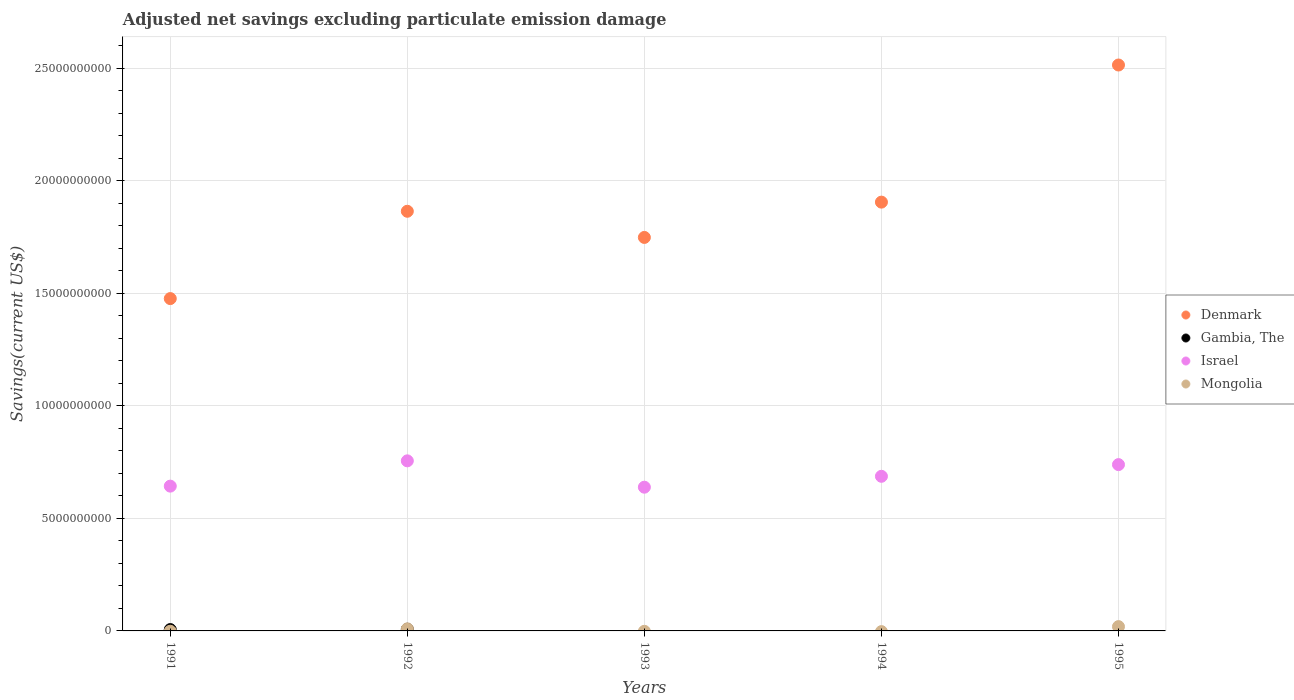How many different coloured dotlines are there?
Offer a very short reply. 4. What is the adjusted net savings in Mongolia in 1991?
Provide a short and direct response. 0. Across all years, what is the maximum adjusted net savings in Israel?
Ensure brevity in your answer.  7.56e+09. Across all years, what is the minimum adjusted net savings in Denmark?
Make the answer very short. 1.48e+1. In which year was the adjusted net savings in Mongolia maximum?
Give a very brief answer. 1995. What is the total adjusted net savings in Denmark in the graph?
Provide a succinct answer. 9.51e+1. What is the difference between the adjusted net savings in Denmark in 1991 and that in 1992?
Keep it short and to the point. -3.88e+09. What is the difference between the adjusted net savings in Gambia, The in 1993 and the adjusted net savings in Mongolia in 1992?
Give a very brief answer. -9.14e+07. What is the average adjusted net savings in Gambia, The per year?
Your answer should be compact. 2.71e+07. In the year 1995, what is the difference between the adjusted net savings in Israel and adjusted net savings in Denmark?
Ensure brevity in your answer.  -1.78e+1. In how many years, is the adjusted net savings in Israel greater than 10000000000 US$?
Your answer should be compact. 0. What is the ratio of the adjusted net savings in Denmark in 1992 to that in 1995?
Keep it short and to the point. 0.74. Is the difference between the adjusted net savings in Israel in 1993 and 1994 greater than the difference between the adjusted net savings in Denmark in 1993 and 1994?
Offer a very short reply. Yes. What is the difference between the highest and the second highest adjusted net savings in Denmark?
Provide a succinct answer. 6.10e+09. What is the difference between the highest and the lowest adjusted net savings in Mongolia?
Your answer should be very brief. 1.91e+08. In how many years, is the adjusted net savings in Israel greater than the average adjusted net savings in Israel taken over all years?
Make the answer very short. 2. Does the adjusted net savings in Denmark monotonically increase over the years?
Offer a terse response. No. Is the adjusted net savings in Gambia, The strictly greater than the adjusted net savings in Israel over the years?
Provide a succinct answer. No. Is the adjusted net savings in Gambia, The strictly less than the adjusted net savings in Israel over the years?
Your answer should be very brief. Yes. How many dotlines are there?
Your answer should be very brief. 4. Are the values on the major ticks of Y-axis written in scientific E-notation?
Offer a very short reply. No. Does the graph contain any zero values?
Offer a very short reply. Yes. Where does the legend appear in the graph?
Keep it short and to the point. Center right. How many legend labels are there?
Provide a short and direct response. 4. How are the legend labels stacked?
Provide a succinct answer. Vertical. What is the title of the graph?
Ensure brevity in your answer.  Adjusted net savings excluding particulate emission damage. What is the label or title of the X-axis?
Make the answer very short. Years. What is the label or title of the Y-axis?
Your response must be concise. Savings(current US$). What is the Savings(current US$) in Denmark in 1991?
Offer a terse response. 1.48e+1. What is the Savings(current US$) in Gambia, The in 1991?
Your response must be concise. 5.98e+07. What is the Savings(current US$) of Israel in 1991?
Your answer should be compact. 6.44e+09. What is the Savings(current US$) of Denmark in 1992?
Keep it short and to the point. 1.87e+1. What is the Savings(current US$) of Gambia, The in 1992?
Ensure brevity in your answer.  7.57e+07. What is the Savings(current US$) in Israel in 1992?
Provide a short and direct response. 7.56e+09. What is the Savings(current US$) of Mongolia in 1992?
Keep it short and to the point. 9.14e+07. What is the Savings(current US$) of Denmark in 1993?
Give a very brief answer. 1.75e+1. What is the Savings(current US$) in Israel in 1993?
Ensure brevity in your answer.  6.39e+09. What is the Savings(current US$) in Denmark in 1994?
Your answer should be compact. 1.91e+1. What is the Savings(current US$) in Israel in 1994?
Provide a short and direct response. 6.87e+09. What is the Savings(current US$) in Denmark in 1995?
Ensure brevity in your answer.  2.52e+1. What is the Savings(current US$) in Israel in 1995?
Keep it short and to the point. 7.39e+09. What is the Savings(current US$) in Mongolia in 1995?
Your answer should be compact. 1.91e+08. Across all years, what is the maximum Savings(current US$) of Denmark?
Offer a terse response. 2.52e+1. Across all years, what is the maximum Savings(current US$) of Gambia, The?
Your response must be concise. 7.57e+07. Across all years, what is the maximum Savings(current US$) of Israel?
Provide a short and direct response. 7.56e+09. Across all years, what is the maximum Savings(current US$) in Mongolia?
Your answer should be compact. 1.91e+08. Across all years, what is the minimum Savings(current US$) of Denmark?
Your response must be concise. 1.48e+1. Across all years, what is the minimum Savings(current US$) in Gambia, The?
Your answer should be very brief. 0. Across all years, what is the minimum Savings(current US$) of Israel?
Make the answer very short. 6.39e+09. Across all years, what is the minimum Savings(current US$) in Mongolia?
Provide a short and direct response. 0. What is the total Savings(current US$) in Denmark in the graph?
Keep it short and to the point. 9.51e+1. What is the total Savings(current US$) of Gambia, The in the graph?
Offer a very short reply. 1.35e+08. What is the total Savings(current US$) of Israel in the graph?
Make the answer very short. 3.47e+1. What is the total Savings(current US$) of Mongolia in the graph?
Your response must be concise. 2.83e+08. What is the difference between the Savings(current US$) in Denmark in 1991 and that in 1992?
Your answer should be very brief. -3.88e+09. What is the difference between the Savings(current US$) of Gambia, The in 1991 and that in 1992?
Provide a succinct answer. -1.58e+07. What is the difference between the Savings(current US$) of Israel in 1991 and that in 1992?
Give a very brief answer. -1.12e+09. What is the difference between the Savings(current US$) in Denmark in 1991 and that in 1993?
Offer a very short reply. -2.72e+09. What is the difference between the Savings(current US$) of Israel in 1991 and that in 1993?
Offer a terse response. 4.69e+07. What is the difference between the Savings(current US$) in Denmark in 1991 and that in 1994?
Your answer should be compact. -4.29e+09. What is the difference between the Savings(current US$) of Israel in 1991 and that in 1994?
Provide a short and direct response. -4.37e+08. What is the difference between the Savings(current US$) in Denmark in 1991 and that in 1995?
Offer a very short reply. -1.04e+1. What is the difference between the Savings(current US$) in Israel in 1991 and that in 1995?
Make the answer very short. -9.57e+08. What is the difference between the Savings(current US$) in Denmark in 1992 and that in 1993?
Provide a short and direct response. 1.16e+09. What is the difference between the Savings(current US$) of Israel in 1992 and that in 1993?
Ensure brevity in your answer.  1.17e+09. What is the difference between the Savings(current US$) of Denmark in 1992 and that in 1994?
Provide a succinct answer. -4.06e+08. What is the difference between the Savings(current US$) in Israel in 1992 and that in 1994?
Give a very brief answer. 6.87e+08. What is the difference between the Savings(current US$) of Denmark in 1992 and that in 1995?
Give a very brief answer. -6.50e+09. What is the difference between the Savings(current US$) of Israel in 1992 and that in 1995?
Provide a short and direct response. 1.68e+08. What is the difference between the Savings(current US$) in Mongolia in 1992 and that in 1995?
Provide a short and direct response. -9.98e+07. What is the difference between the Savings(current US$) of Denmark in 1993 and that in 1994?
Provide a succinct answer. -1.57e+09. What is the difference between the Savings(current US$) of Israel in 1993 and that in 1994?
Ensure brevity in your answer.  -4.84e+08. What is the difference between the Savings(current US$) in Denmark in 1993 and that in 1995?
Keep it short and to the point. -7.66e+09. What is the difference between the Savings(current US$) of Israel in 1993 and that in 1995?
Keep it short and to the point. -1.00e+09. What is the difference between the Savings(current US$) in Denmark in 1994 and that in 1995?
Your response must be concise. -6.10e+09. What is the difference between the Savings(current US$) of Israel in 1994 and that in 1995?
Give a very brief answer. -5.19e+08. What is the difference between the Savings(current US$) in Denmark in 1991 and the Savings(current US$) in Gambia, The in 1992?
Make the answer very short. 1.47e+1. What is the difference between the Savings(current US$) in Denmark in 1991 and the Savings(current US$) in Israel in 1992?
Ensure brevity in your answer.  7.21e+09. What is the difference between the Savings(current US$) of Denmark in 1991 and the Savings(current US$) of Mongolia in 1992?
Give a very brief answer. 1.47e+1. What is the difference between the Savings(current US$) in Gambia, The in 1991 and the Savings(current US$) in Israel in 1992?
Ensure brevity in your answer.  -7.50e+09. What is the difference between the Savings(current US$) in Gambia, The in 1991 and the Savings(current US$) in Mongolia in 1992?
Make the answer very short. -3.15e+07. What is the difference between the Savings(current US$) in Israel in 1991 and the Savings(current US$) in Mongolia in 1992?
Ensure brevity in your answer.  6.34e+09. What is the difference between the Savings(current US$) of Denmark in 1991 and the Savings(current US$) of Israel in 1993?
Provide a succinct answer. 8.38e+09. What is the difference between the Savings(current US$) of Gambia, The in 1991 and the Savings(current US$) of Israel in 1993?
Ensure brevity in your answer.  -6.33e+09. What is the difference between the Savings(current US$) in Denmark in 1991 and the Savings(current US$) in Israel in 1994?
Provide a succinct answer. 7.90e+09. What is the difference between the Savings(current US$) of Gambia, The in 1991 and the Savings(current US$) of Israel in 1994?
Your response must be concise. -6.81e+09. What is the difference between the Savings(current US$) of Denmark in 1991 and the Savings(current US$) of Israel in 1995?
Provide a short and direct response. 7.38e+09. What is the difference between the Savings(current US$) of Denmark in 1991 and the Savings(current US$) of Mongolia in 1995?
Your answer should be very brief. 1.46e+1. What is the difference between the Savings(current US$) in Gambia, The in 1991 and the Savings(current US$) in Israel in 1995?
Provide a succinct answer. -7.33e+09. What is the difference between the Savings(current US$) of Gambia, The in 1991 and the Savings(current US$) of Mongolia in 1995?
Give a very brief answer. -1.31e+08. What is the difference between the Savings(current US$) of Israel in 1991 and the Savings(current US$) of Mongolia in 1995?
Your answer should be very brief. 6.24e+09. What is the difference between the Savings(current US$) of Denmark in 1992 and the Savings(current US$) of Israel in 1993?
Offer a terse response. 1.23e+1. What is the difference between the Savings(current US$) in Gambia, The in 1992 and the Savings(current US$) in Israel in 1993?
Give a very brief answer. -6.31e+09. What is the difference between the Savings(current US$) of Denmark in 1992 and the Savings(current US$) of Israel in 1994?
Offer a terse response. 1.18e+1. What is the difference between the Savings(current US$) in Gambia, The in 1992 and the Savings(current US$) in Israel in 1994?
Your answer should be very brief. -6.80e+09. What is the difference between the Savings(current US$) in Denmark in 1992 and the Savings(current US$) in Israel in 1995?
Offer a terse response. 1.13e+1. What is the difference between the Savings(current US$) of Denmark in 1992 and the Savings(current US$) of Mongolia in 1995?
Provide a short and direct response. 1.85e+1. What is the difference between the Savings(current US$) of Gambia, The in 1992 and the Savings(current US$) of Israel in 1995?
Your response must be concise. -7.32e+09. What is the difference between the Savings(current US$) in Gambia, The in 1992 and the Savings(current US$) in Mongolia in 1995?
Ensure brevity in your answer.  -1.16e+08. What is the difference between the Savings(current US$) of Israel in 1992 and the Savings(current US$) of Mongolia in 1995?
Offer a terse response. 7.37e+09. What is the difference between the Savings(current US$) in Denmark in 1993 and the Savings(current US$) in Israel in 1994?
Provide a succinct answer. 1.06e+1. What is the difference between the Savings(current US$) in Denmark in 1993 and the Savings(current US$) in Israel in 1995?
Give a very brief answer. 1.01e+1. What is the difference between the Savings(current US$) of Denmark in 1993 and the Savings(current US$) of Mongolia in 1995?
Keep it short and to the point. 1.73e+1. What is the difference between the Savings(current US$) in Israel in 1993 and the Savings(current US$) in Mongolia in 1995?
Your response must be concise. 6.20e+09. What is the difference between the Savings(current US$) in Denmark in 1994 and the Savings(current US$) in Israel in 1995?
Your response must be concise. 1.17e+1. What is the difference between the Savings(current US$) of Denmark in 1994 and the Savings(current US$) of Mongolia in 1995?
Provide a short and direct response. 1.89e+1. What is the difference between the Savings(current US$) of Israel in 1994 and the Savings(current US$) of Mongolia in 1995?
Provide a short and direct response. 6.68e+09. What is the average Savings(current US$) in Denmark per year?
Provide a short and direct response. 1.90e+1. What is the average Savings(current US$) of Gambia, The per year?
Offer a terse response. 2.71e+07. What is the average Savings(current US$) of Israel per year?
Offer a terse response. 6.93e+09. What is the average Savings(current US$) of Mongolia per year?
Keep it short and to the point. 5.65e+07. In the year 1991, what is the difference between the Savings(current US$) in Denmark and Savings(current US$) in Gambia, The?
Offer a very short reply. 1.47e+1. In the year 1991, what is the difference between the Savings(current US$) of Denmark and Savings(current US$) of Israel?
Provide a short and direct response. 8.34e+09. In the year 1991, what is the difference between the Savings(current US$) in Gambia, The and Savings(current US$) in Israel?
Ensure brevity in your answer.  -6.38e+09. In the year 1992, what is the difference between the Savings(current US$) in Denmark and Savings(current US$) in Gambia, The?
Offer a terse response. 1.86e+1. In the year 1992, what is the difference between the Savings(current US$) in Denmark and Savings(current US$) in Israel?
Your response must be concise. 1.11e+1. In the year 1992, what is the difference between the Savings(current US$) in Denmark and Savings(current US$) in Mongolia?
Make the answer very short. 1.86e+1. In the year 1992, what is the difference between the Savings(current US$) of Gambia, The and Savings(current US$) of Israel?
Provide a succinct answer. -7.48e+09. In the year 1992, what is the difference between the Savings(current US$) in Gambia, The and Savings(current US$) in Mongolia?
Give a very brief answer. -1.57e+07. In the year 1992, what is the difference between the Savings(current US$) of Israel and Savings(current US$) of Mongolia?
Make the answer very short. 7.47e+09. In the year 1993, what is the difference between the Savings(current US$) in Denmark and Savings(current US$) in Israel?
Give a very brief answer. 1.11e+1. In the year 1994, what is the difference between the Savings(current US$) in Denmark and Savings(current US$) in Israel?
Provide a succinct answer. 1.22e+1. In the year 1995, what is the difference between the Savings(current US$) in Denmark and Savings(current US$) in Israel?
Offer a very short reply. 1.78e+1. In the year 1995, what is the difference between the Savings(current US$) of Denmark and Savings(current US$) of Mongolia?
Your answer should be compact. 2.50e+1. In the year 1995, what is the difference between the Savings(current US$) in Israel and Savings(current US$) in Mongolia?
Ensure brevity in your answer.  7.20e+09. What is the ratio of the Savings(current US$) in Denmark in 1991 to that in 1992?
Offer a terse response. 0.79. What is the ratio of the Savings(current US$) of Gambia, The in 1991 to that in 1992?
Offer a very short reply. 0.79. What is the ratio of the Savings(current US$) in Israel in 1991 to that in 1992?
Ensure brevity in your answer.  0.85. What is the ratio of the Savings(current US$) of Denmark in 1991 to that in 1993?
Keep it short and to the point. 0.84. What is the ratio of the Savings(current US$) in Israel in 1991 to that in 1993?
Offer a terse response. 1.01. What is the ratio of the Savings(current US$) of Denmark in 1991 to that in 1994?
Give a very brief answer. 0.78. What is the ratio of the Savings(current US$) in Israel in 1991 to that in 1994?
Ensure brevity in your answer.  0.94. What is the ratio of the Savings(current US$) of Denmark in 1991 to that in 1995?
Keep it short and to the point. 0.59. What is the ratio of the Savings(current US$) of Israel in 1991 to that in 1995?
Offer a very short reply. 0.87. What is the ratio of the Savings(current US$) of Denmark in 1992 to that in 1993?
Provide a succinct answer. 1.07. What is the ratio of the Savings(current US$) of Israel in 1992 to that in 1993?
Your answer should be compact. 1.18. What is the ratio of the Savings(current US$) in Denmark in 1992 to that in 1994?
Ensure brevity in your answer.  0.98. What is the ratio of the Savings(current US$) in Israel in 1992 to that in 1994?
Your response must be concise. 1.1. What is the ratio of the Savings(current US$) in Denmark in 1992 to that in 1995?
Make the answer very short. 0.74. What is the ratio of the Savings(current US$) in Israel in 1992 to that in 1995?
Provide a short and direct response. 1.02. What is the ratio of the Savings(current US$) in Mongolia in 1992 to that in 1995?
Your response must be concise. 0.48. What is the ratio of the Savings(current US$) in Denmark in 1993 to that in 1994?
Offer a terse response. 0.92. What is the ratio of the Savings(current US$) of Israel in 1993 to that in 1994?
Offer a very short reply. 0.93. What is the ratio of the Savings(current US$) of Denmark in 1993 to that in 1995?
Offer a terse response. 0.7. What is the ratio of the Savings(current US$) of Israel in 1993 to that in 1995?
Offer a terse response. 0.86. What is the ratio of the Savings(current US$) of Denmark in 1994 to that in 1995?
Keep it short and to the point. 0.76. What is the ratio of the Savings(current US$) in Israel in 1994 to that in 1995?
Your answer should be compact. 0.93. What is the difference between the highest and the second highest Savings(current US$) of Denmark?
Offer a terse response. 6.10e+09. What is the difference between the highest and the second highest Savings(current US$) in Israel?
Make the answer very short. 1.68e+08. What is the difference between the highest and the lowest Savings(current US$) of Denmark?
Make the answer very short. 1.04e+1. What is the difference between the highest and the lowest Savings(current US$) in Gambia, The?
Make the answer very short. 7.57e+07. What is the difference between the highest and the lowest Savings(current US$) in Israel?
Your response must be concise. 1.17e+09. What is the difference between the highest and the lowest Savings(current US$) in Mongolia?
Ensure brevity in your answer.  1.91e+08. 